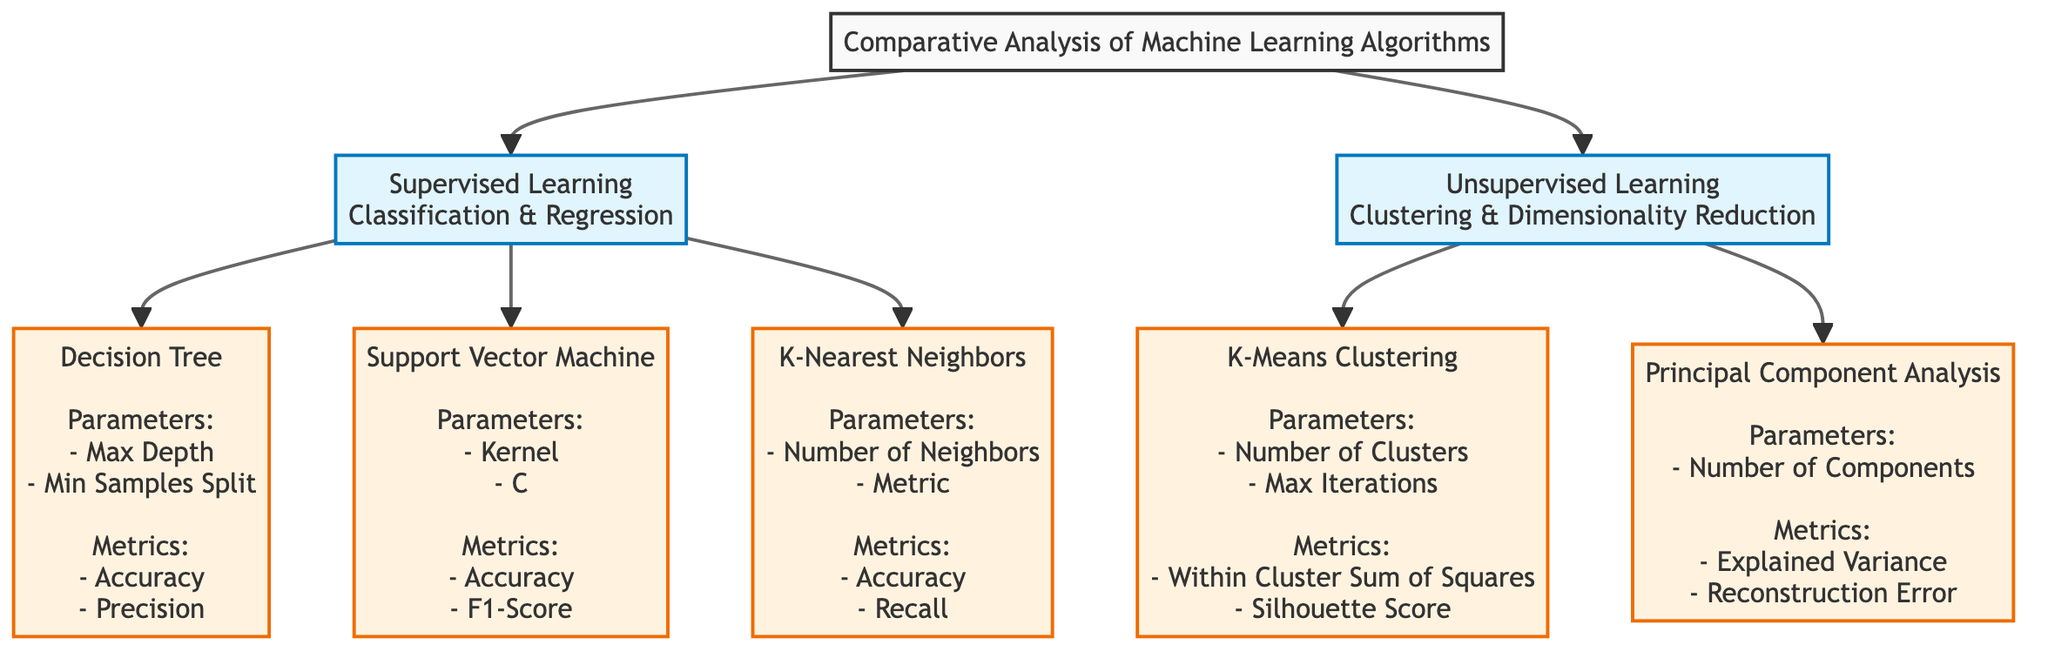What are the two main categories of machine learning illustrated in the diagram? The diagram shows two main categories: "Supervised Learning" and "Unsupervised Learning." These categories can be identified directly from the two main nodes stemming from the title.
Answer: Supervised Learning, Unsupervised Learning Which machine learning algorithm is associated with the parameter "Kernel"? The "Support Vector Machine" node mentions "Kernel" as one of its parameters. This relationship can be recognized as each algorithm node has specific parameters listed beneath them.
Answer: Support Vector Machine How many supervised learning algorithms are presented in the diagram? The diagram has three nodes connected under the "Supervised Learning" category: Decision Tree, Support Vector Machine, and K-Nearest Neighbors. Counting these nodes gives the total number of supervised algorithms listed.
Answer: 3 Which algorithm includes "Within Cluster Sum of Squares" as a performance metric? The "K-Means Clustering" node lists "Within Cluster Sum of Squares" as one of its metrics. This can be determined by reviewing the metrics listed under each algorithm node.
Answer: K-Means Clustering What is a key parameter of the Decision Tree algorithm? The "Decision Tree" node mentions "Max Depth" as one of its parameters. This is noted directly in the text details of that particular algorithm node.
Answer: Max Depth How many performance metrics are associated with the K-Nearest Neighbors algorithm? The "K-Nearest Neighbors" node lists two performance metrics: "Accuracy" and "Recall." Counting these metrics provides the required number.
Answer: 2 Which unsupervised learning algorithm has a focus on dimensionality reduction? The "Principal Component Analysis" node is specifically noted for dimensionality reduction, which is a key aspect of its functionality in the context of unsupervised learning algorithms.
Answer: Principal Component Analysis What performance metric is commonly used for classification algorithms according to the diagram? The diagram indicates "Accuracy" as a performance metric under both "Decision Tree" and "K-Nearest Neighbors," demonstrating its commonality across classification algorithms.
Answer: Accuracy Which supervised learning algorithm requires the parameter "Min Samples Split"? The "Decision Tree" node indicates "Min Samples Split" as one of its parameters, which is specifically listed under that algorithm.
Answer: Decision Tree 